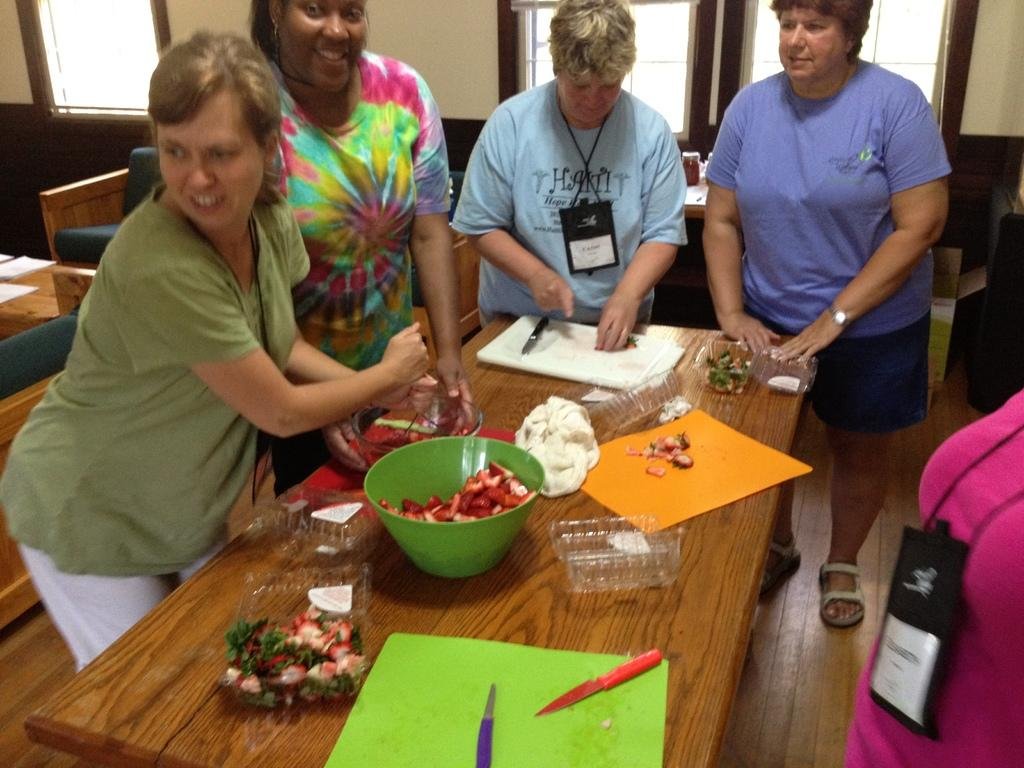How many people are in the image? There are persons standing in the image, but the exact number cannot be determined from the provided facts. What is on the table in the image? There is a box, a knife, a bowl, fruits, and a cloth on the table in the image. What can be seen in the background of the image? There is a wall and a window in the background of the image. What type of seating is present in the image? There are chairs in the image. What type of meat is being prepared on the table in the image? There is no meat present in the image; the table contains a box, a knife, a bowl, fruits, and a cloth. Can you see a toad sitting on the table in the image? There is no toad present in the image; the table contains a box, a knife, a bowl, fruits, and a cloth. 